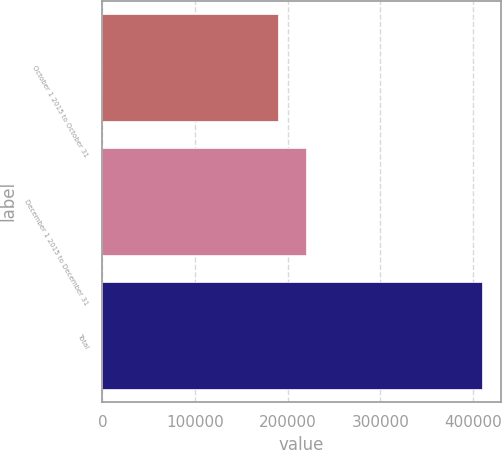Convert chart to OTSL. <chart><loc_0><loc_0><loc_500><loc_500><bar_chart><fcel>October 1 2015 to October 31<fcel>December 1 2015 to December 31<fcel>Total<nl><fcel>189470<fcel>219803<fcel>409273<nl></chart> 